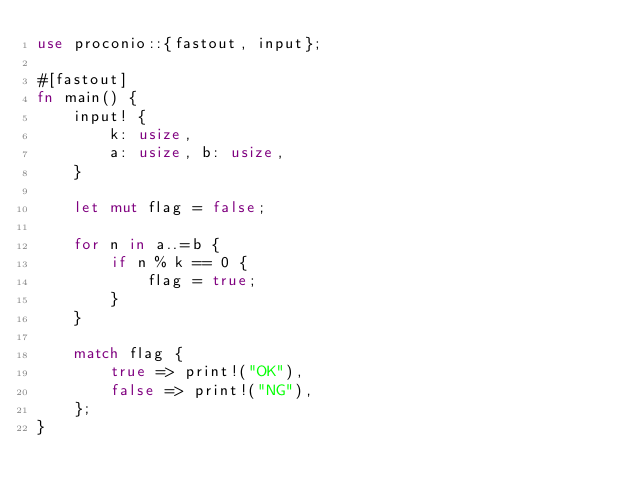<code> <loc_0><loc_0><loc_500><loc_500><_Rust_>use proconio::{fastout, input};

#[fastout]
fn main() {
    input! {
        k: usize,
        a: usize, b: usize,
    }

    let mut flag = false;

    for n in a..=b {
        if n % k == 0 {
            flag = true;
        }
    }

    match flag {
        true => print!("OK"),
        false => print!("NG"),
    };
}
</code> 